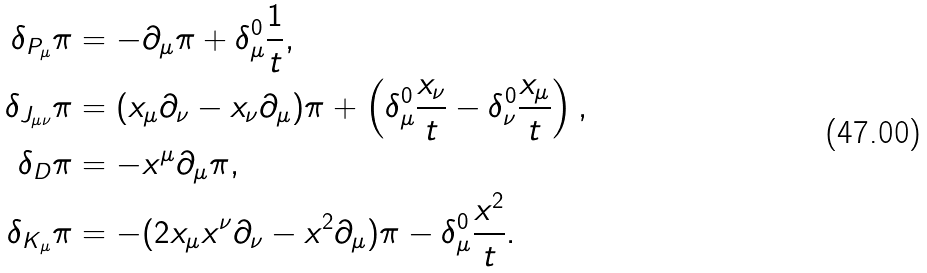Convert formula to latex. <formula><loc_0><loc_0><loc_500><loc_500>\delta _ { P _ { \mu } } \pi & = - \partial _ { \mu } \pi + \delta _ { \mu } ^ { 0 } \frac { 1 } { t } , \\ \delta _ { J _ { \mu \nu } } \pi & = ( x _ { \mu } \partial _ { \nu } - x _ { \nu } \partial _ { \mu } ) \pi + \left ( \delta ^ { 0 } _ { \mu } \frac { x _ { \nu } } { t } - \delta ^ { 0 } _ { \nu } \frac { x _ { \mu } } { t } \right ) , \\ \delta _ { D } \pi & = - x ^ { \mu } \partial _ { \mu } \pi , \\ \delta _ { K _ { \mu } } \pi & = - ( 2 x _ { \mu } x ^ { \nu } \partial _ { \nu } - x ^ { 2 } \partial _ { \mu } ) \pi - \delta _ { \mu } ^ { 0 } \frac { x ^ { 2 } } { t } .</formula> 